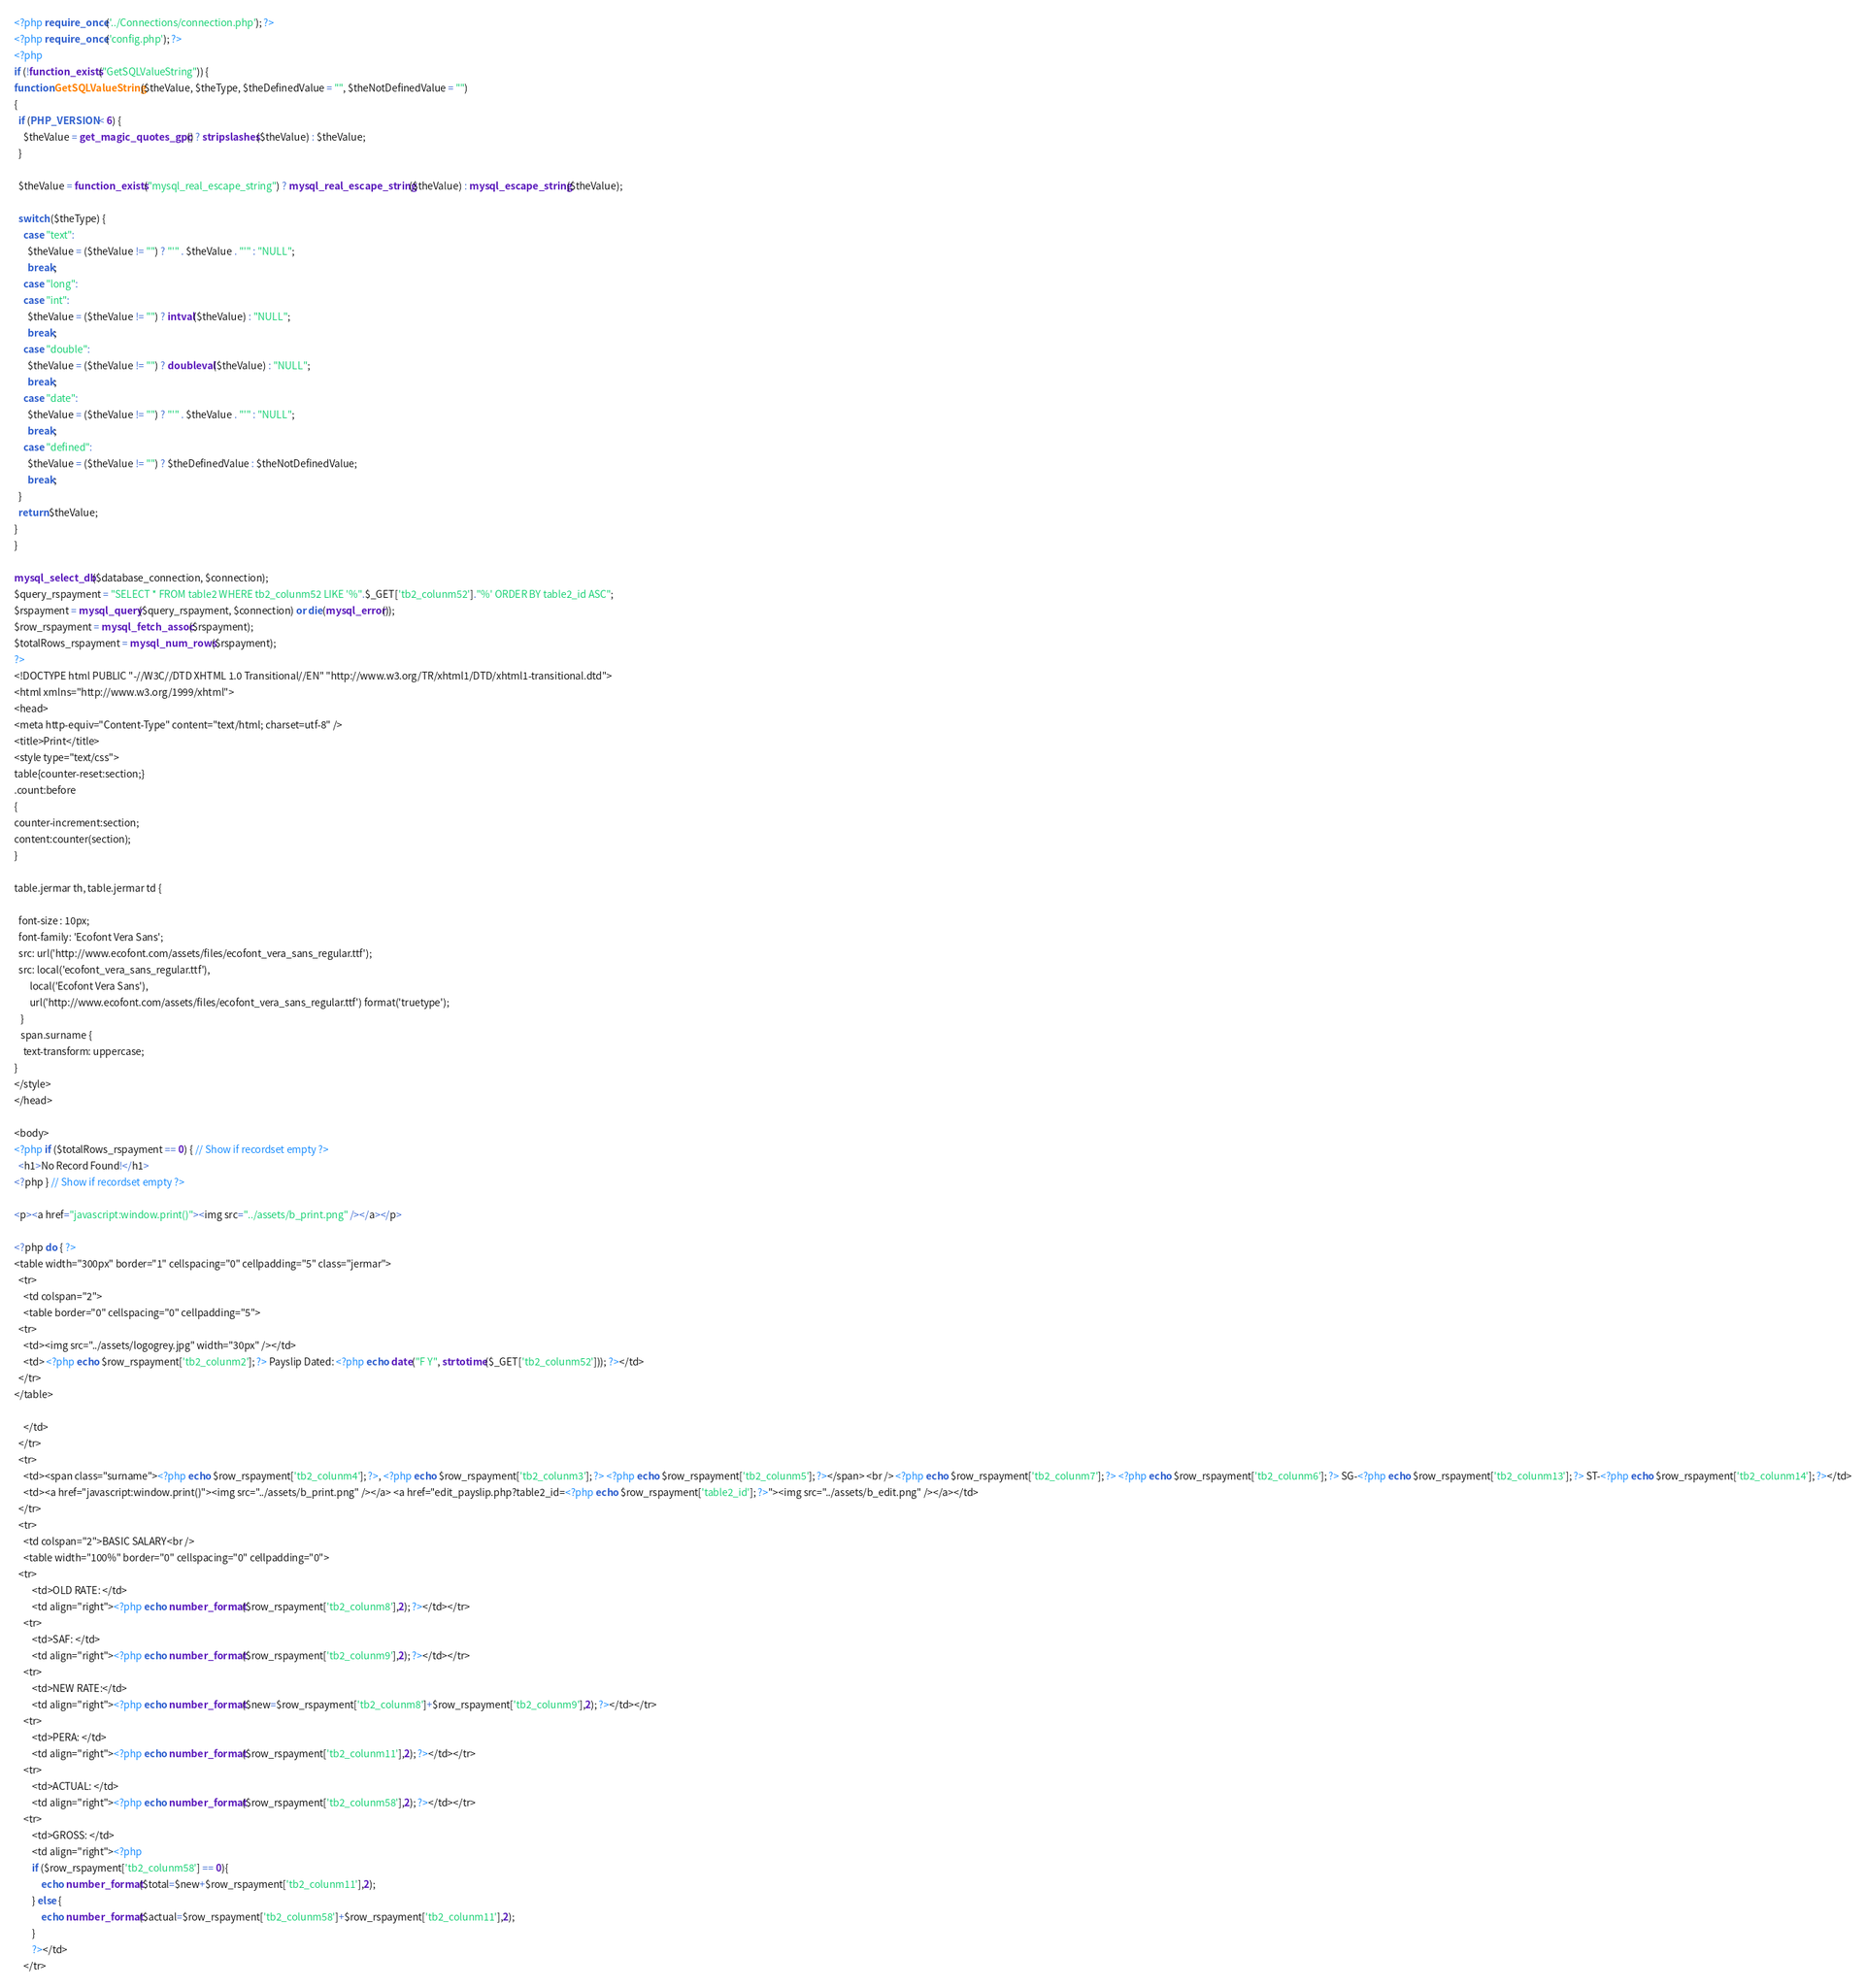<code> <loc_0><loc_0><loc_500><loc_500><_PHP_><?php require_once('../Connections/connection.php'); ?>
<?php require_once('config.php'); ?>
<?php
if (!function_exists("GetSQLValueString")) {
function GetSQLValueString($theValue, $theType, $theDefinedValue = "", $theNotDefinedValue = "") 
{
  if (PHP_VERSION < 6) {
    $theValue = get_magic_quotes_gpc() ? stripslashes($theValue) : $theValue;
  }

  $theValue = function_exists("mysql_real_escape_string") ? mysql_real_escape_string($theValue) : mysql_escape_string($theValue);

  switch ($theType) {
    case "text":
      $theValue = ($theValue != "") ? "'" . $theValue . "'" : "NULL";
      break;    
    case "long":
    case "int":
      $theValue = ($theValue != "") ? intval($theValue) : "NULL";
      break;
    case "double":
      $theValue = ($theValue != "") ? doubleval($theValue) : "NULL";
      break;
    case "date":
      $theValue = ($theValue != "") ? "'" . $theValue . "'" : "NULL";
      break;
    case "defined":
      $theValue = ($theValue != "") ? $theDefinedValue : $theNotDefinedValue;
      break;
  }
  return $theValue;
}
}

mysql_select_db($database_connection, $connection);
$query_rspayment = "SELECT * FROM table2 WHERE tb2_colunm52 LIKE '%".$_GET['tb2_colunm52']."%' ORDER BY table2_id ASC";
$rspayment = mysql_query($query_rspayment, $connection) or die(mysql_error());
$row_rspayment = mysql_fetch_assoc($rspayment);
$totalRows_rspayment = mysql_num_rows($rspayment);
?>
<!DOCTYPE html PUBLIC "-//W3C//DTD XHTML 1.0 Transitional//EN" "http://www.w3.org/TR/xhtml1/DTD/xhtml1-transitional.dtd">
<html xmlns="http://www.w3.org/1999/xhtml">
<head>
<meta http-equiv="Content-Type" content="text/html; charset=utf-8" />
<title>Print</title>
<style type="text/css">
table{counter-reset:section;}
.count:before
{
counter-increment:section;
content:counter(section);
} 

table.jermar th, table.jermar td {
  
  font-size : 10px;
  font-family: 'Ecofont Vera Sans';
  src: url('http://www.ecofont.com/assets/files/ecofont_vera_sans_regular.ttf');
  src: local('ecofont_vera_sans_regular.ttf'), 
       local('Ecofont Vera Sans'), 
       url('http://www.ecofont.com/assets/files/ecofont_vera_sans_regular.ttf') format('truetype');
   }
   span.surname {
    text-transform: uppercase;
}
</style>
</head>

<body>
<?php if ($totalRows_rspayment == 0) { // Show if recordset empty ?>
  <h1>No Record Found!</h1>
<?php } // Show if recordset empty ?>

<p><a href="javascript:window.print()"><img src="../assets/b_print.png" /></a></p>

<?php do { ?>
<table width="300px" border="1" cellspacing="0" cellpadding="5" class="jermar">
  <tr>
    <td colspan="2">
    <table border="0" cellspacing="0" cellpadding="5">
  <tr>
    <td><img src="../assets/logogrey.jpg" width="30px" /></td>
    <td> <?php echo $row_rspayment['tb2_colunm2']; ?> Payslip Dated: <?php echo date("F Y", strtotime($_GET['tb2_colunm52'])); ?></td>
  </tr>
</table>

    </td>
  </tr>
  <tr>
    <td><span class="surname"><?php echo $row_rspayment['tb2_colunm4']; ?>, <?php echo $row_rspayment['tb2_colunm3']; ?> <?php echo $row_rspayment['tb2_colunm5']; ?></span> <br /> <?php echo $row_rspayment['tb2_colunm7']; ?> <?php echo $row_rspayment['tb2_colunm6']; ?> SG-<?php echo $row_rspayment['tb2_colunm13']; ?> ST-<?php echo $row_rspayment['tb2_colunm14']; ?></td>
    <td><a href="javascript:window.print()"><img src="../assets/b_print.png" /></a> <a href="edit_payslip.php?table2_id=<?php echo $row_rspayment['table2_id']; ?>"><img src="../assets/b_edit.png" /></a></td>
  </tr>
  <tr>
    <td colspan="2">BASIC SALARY<br />
    <table width="100%" border="0" cellspacing="0" cellpadding="0">
  <tr>
		<td>OLD RATE: </td>
		<td align="right"><?php echo number_format($row_rspayment['tb2_colunm8'],2); ?></td></tr>
	<tr>
    	<td>SAF: </td>
        <td align="right"><?php echo number_format($row_rspayment['tb2_colunm9'],2); ?></td></tr>
	<tr>
    	<td>NEW RATE:</td>
        <td align="right"><?php echo number_format($new=$row_rspayment['tb2_colunm8']+$row_rspayment['tb2_colunm9'],2); ?></td></tr>
	<tr>
    	<td>PERA: </td>
		<td align="right"><?php echo number_format($row_rspayment['tb2_colunm11'],2); ?></td></tr>
	<tr>
    	<td>ACTUAL: </td>
		<td align="right"><?php echo number_format($row_rspayment['tb2_colunm58'],2); ?></td></tr>
	<tr>
    	<td>GROSS: </td>
		<td align="right"><?php
    	if ($row_rspayment['tb2_colunm58'] == 0){
			echo number_format($total=$new+$row_rspayment['tb2_colunm11'],2);
		} else {
			echo number_format($actual=$row_rspayment['tb2_colunm58']+$row_rspayment['tb2_colunm11'],2);
		}
		?></td>
    </tr></code> 